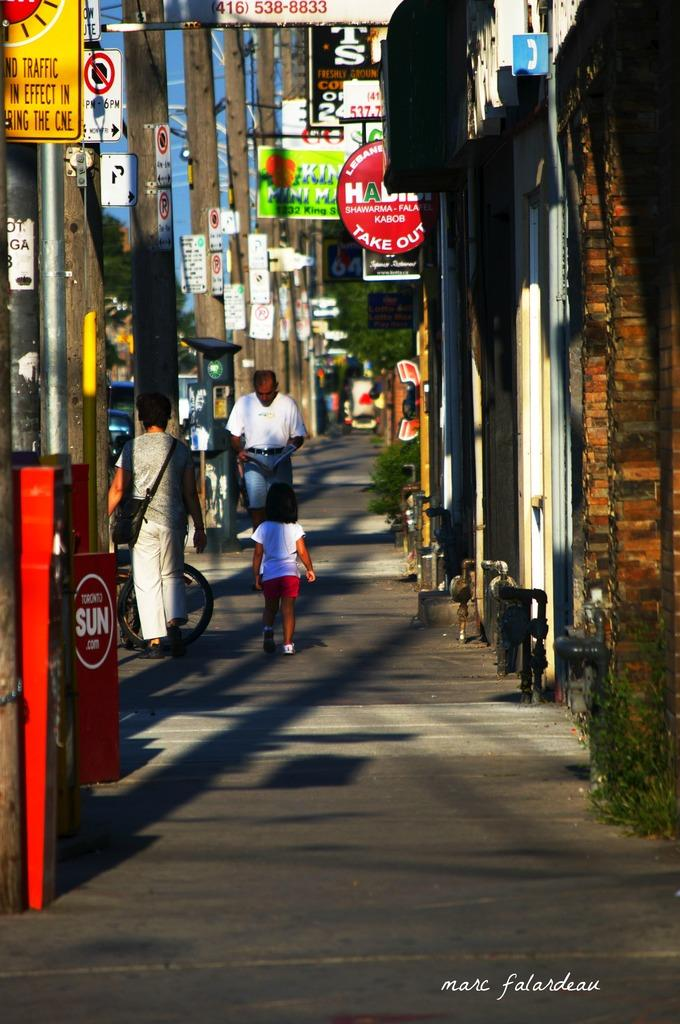<image>
Share a concise interpretation of the image provided. A street with a newspaper box for the Toronto Sun on the side. 